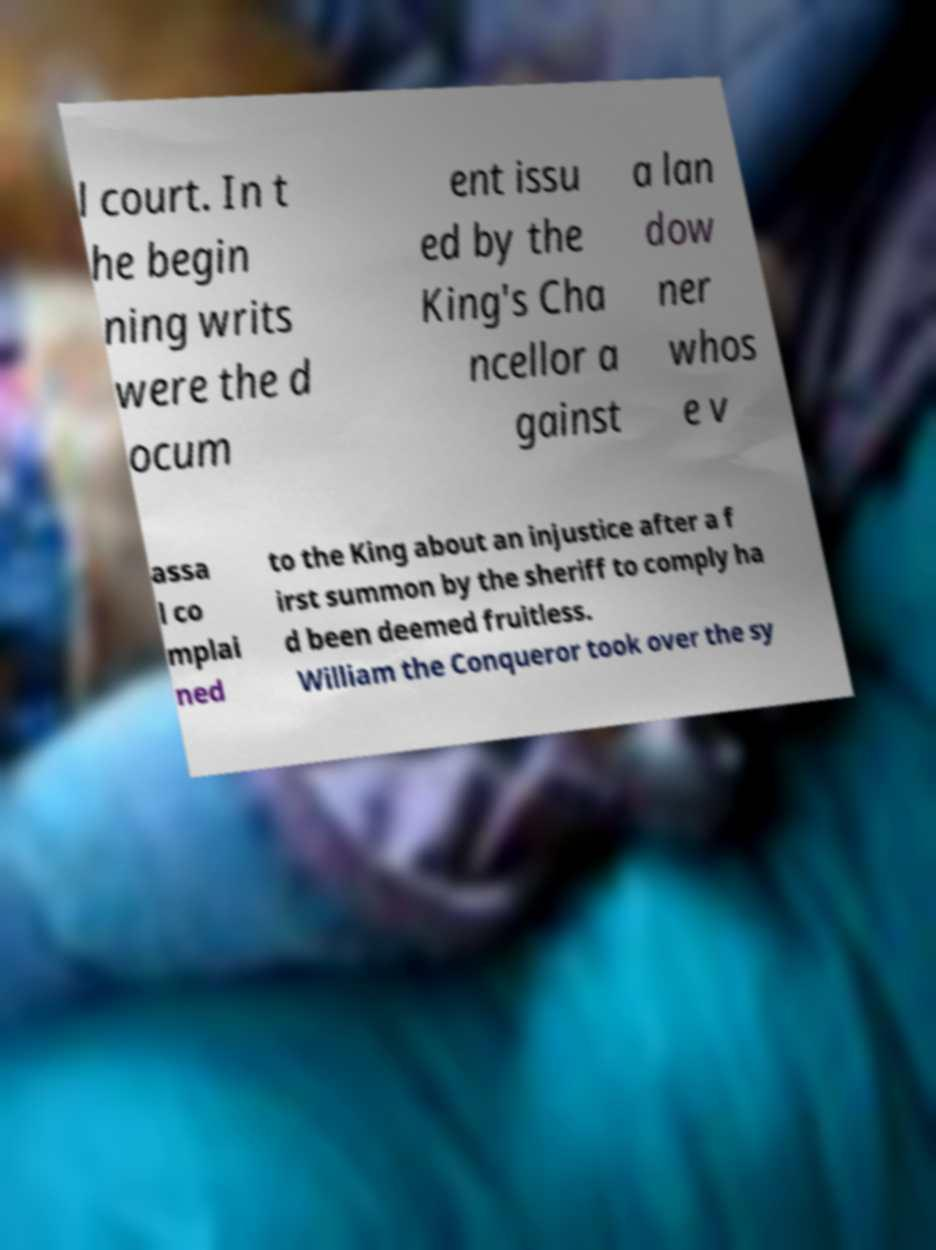Could you assist in decoding the text presented in this image and type it out clearly? l court. In t he begin ning writs were the d ocum ent issu ed by the King's Cha ncellor a gainst a lan dow ner whos e v assa l co mplai ned to the King about an injustice after a f irst summon by the sheriff to comply ha d been deemed fruitless. William the Conqueror took over the sy 